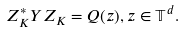<formula> <loc_0><loc_0><loc_500><loc_500>Z _ { K } ^ { * } Y Z _ { K } = Q ( z ) , z \in { \mathbb { T } } ^ { d } .</formula> 